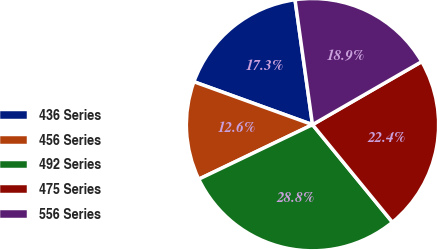Convert chart. <chart><loc_0><loc_0><loc_500><loc_500><pie_chart><fcel>436 Series<fcel>456 Series<fcel>492 Series<fcel>475 Series<fcel>556 Series<nl><fcel>17.26%<fcel>12.64%<fcel>28.81%<fcel>22.41%<fcel>18.88%<nl></chart> 